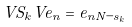<formula> <loc_0><loc_0><loc_500><loc_500>V S _ { k } V e _ { n } = e _ { n N - s _ { k } }</formula> 